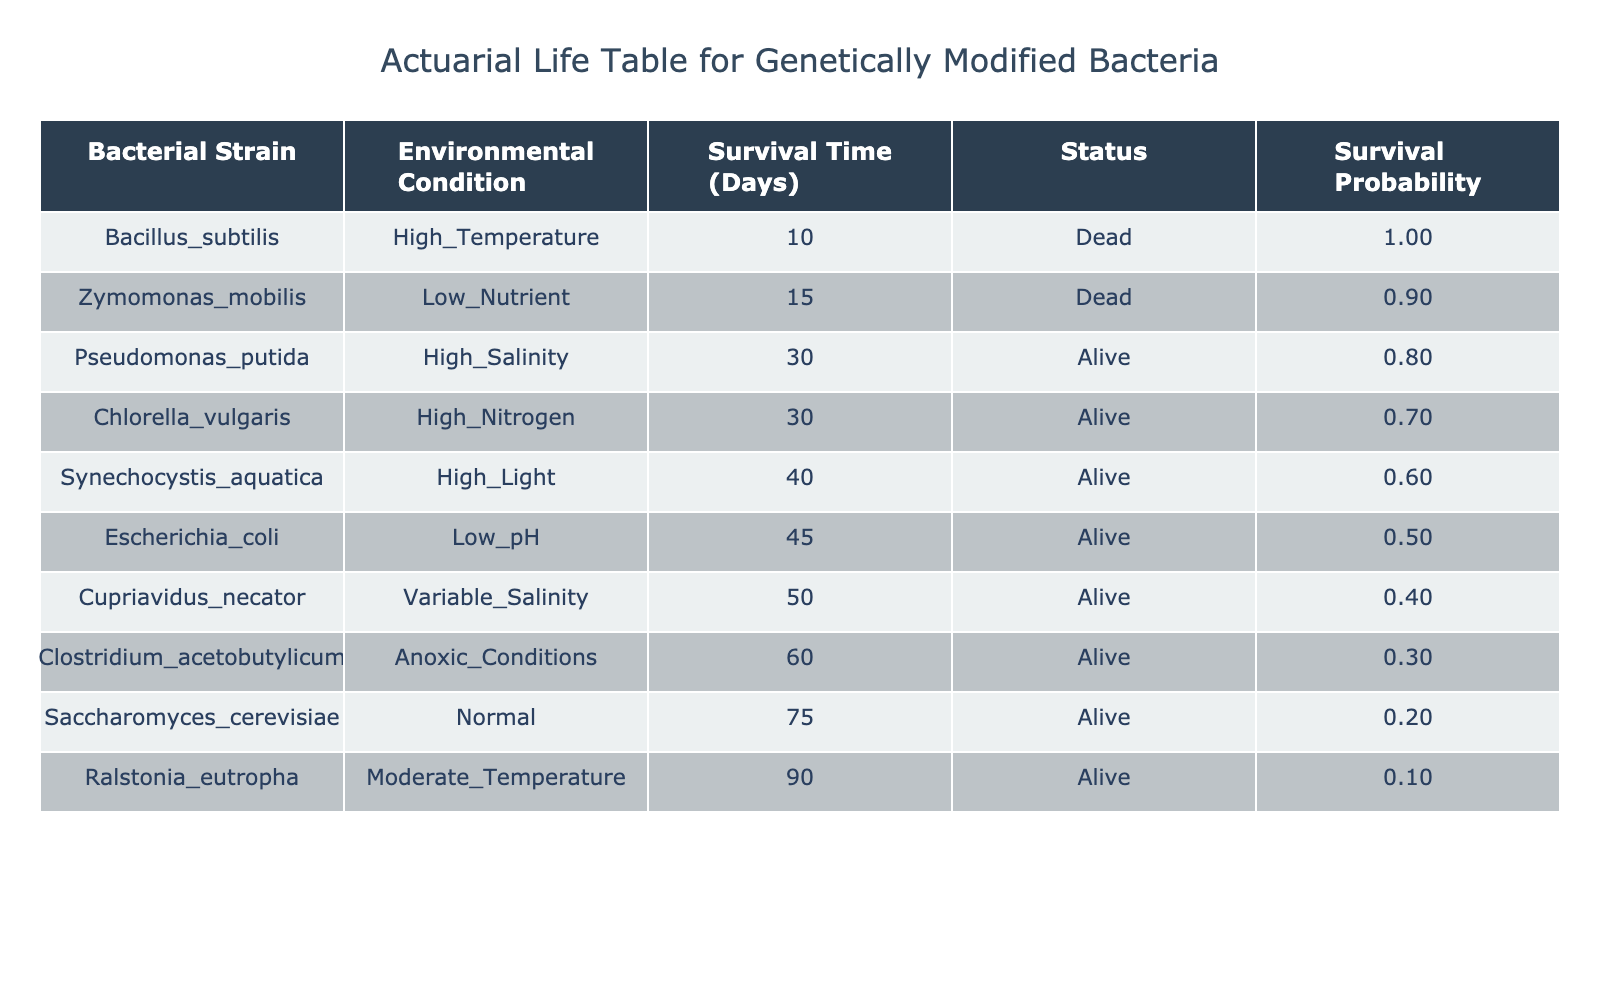What is the survival time of Clostridium acetobutylicum under anoxic conditions? The survival time for Clostridium acetobutylicum is listed in the Survival Time Days column, where it shows 60 days under anoxic conditions.
Answer: 60 Which bacterial strain has the longest survival time? By examining the Survival Time Days column, Ralstonia eutropha has the longest survival time of 90 days.
Answer: Ralstonia eutropha How many bacterial strains were alive at the end of the survival testing? A quick count of the Status column reveals that there are 7 strains marked as Alive out of the total 10 entries.
Answer: 7 Is there any bacterial strain that survived under high temperature? By looking at the Status column for Bacillus subtilis under the High Temperature condition, it is marked as Dead, indicating it did not survive.
Answer: No What is the average survival time of the bacteria that survived? First, sum the survival times of the living strains: 30 + 45 + 60 + 90 + 40 + 75 + 50 + 30 = 420 days. Next, divide this by the count of living strains, which is 7. Hence, the average survival time is 420 / 7 = 60 days.
Answer: 60 Which environmental condition allows the longest survival for the bacteria listed? The longest survival time of 90 days is observed for Ralstonia eutropha under Moderate Temperature, indicating that this environmental condition allows the longest survival.
Answer: Moderate Temperature How many strains are dead due to low nutrient conditions? The Status column indicates that Zymomonas mobilis is dead, which is the only strain listed under Low Nutrient condition, resulting in a total of 1 dead strain.
Answer: 1 Is the survival rate higher among bacteria that are in high salinity environments? By comparing the survival status of strains in the High Salinity environment, only Pseudomonas putida is alive, and since there are no others under this condition, we cannot assess a "higher" survival rate. Although it survived, no comparison can be made.
Answer: No 